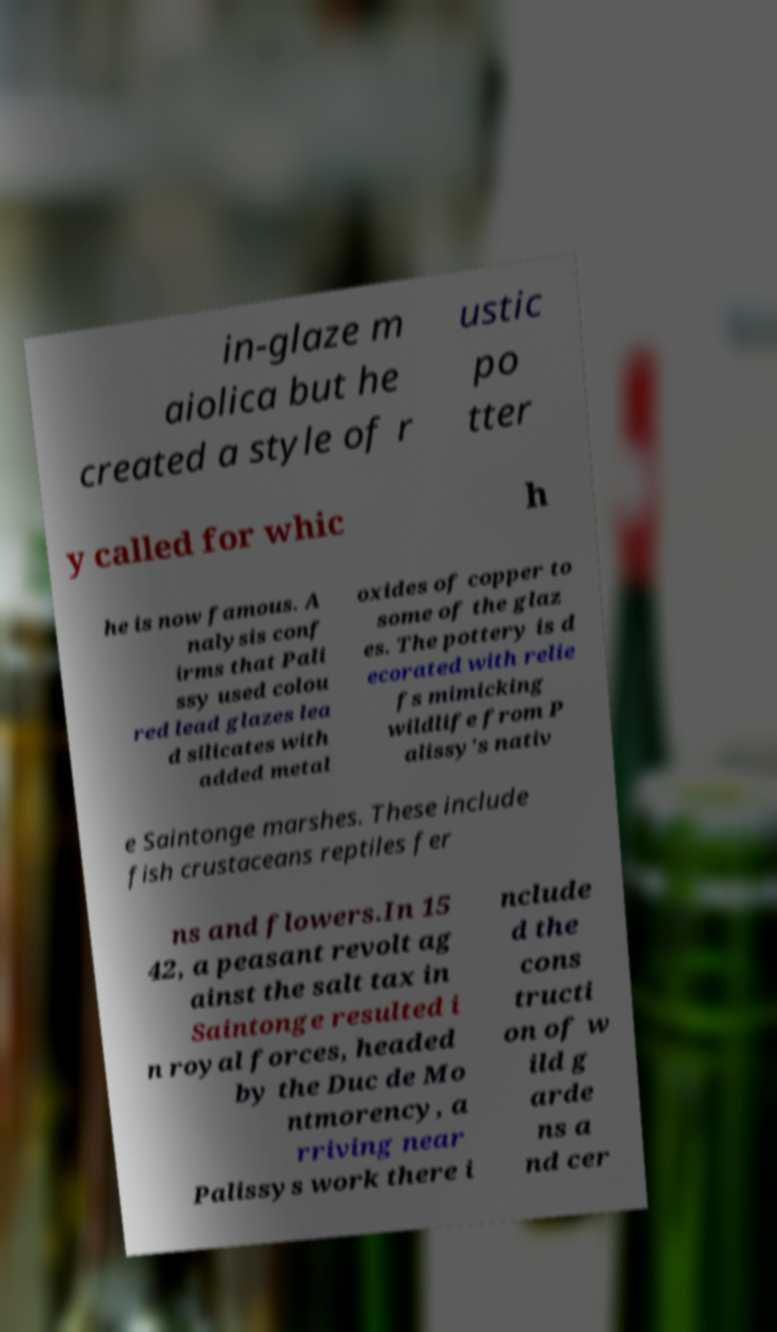Can you accurately transcribe the text from the provided image for me? in-glaze m aiolica but he created a style of r ustic po tter y called for whic h he is now famous. A nalysis conf irms that Pali ssy used colou red lead glazes lea d silicates with added metal oxides of copper to some of the glaz es. The pottery is d ecorated with relie fs mimicking wildlife from P alissy's nativ e Saintonge marshes. These include fish crustaceans reptiles fer ns and flowers.In 15 42, a peasant revolt ag ainst the salt tax in Saintonge resulted i n royal forces, headed by the Duc de Mo ntmorency, a rriving near Palissys work there i nclude d the cons tructi on of w ild g arde ns a nd cer 